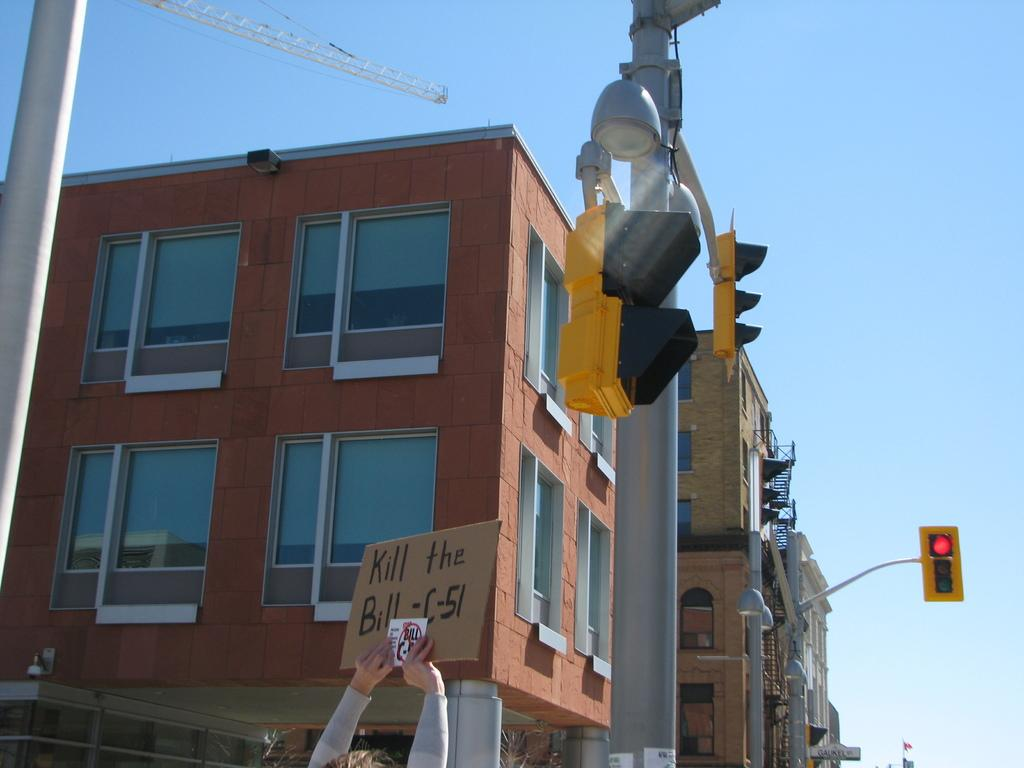<image>
Give a short and clear explanation of the subsequent image. A high brick building with a person holding up a sign with Kill the Bill-c-51 on a card board. 